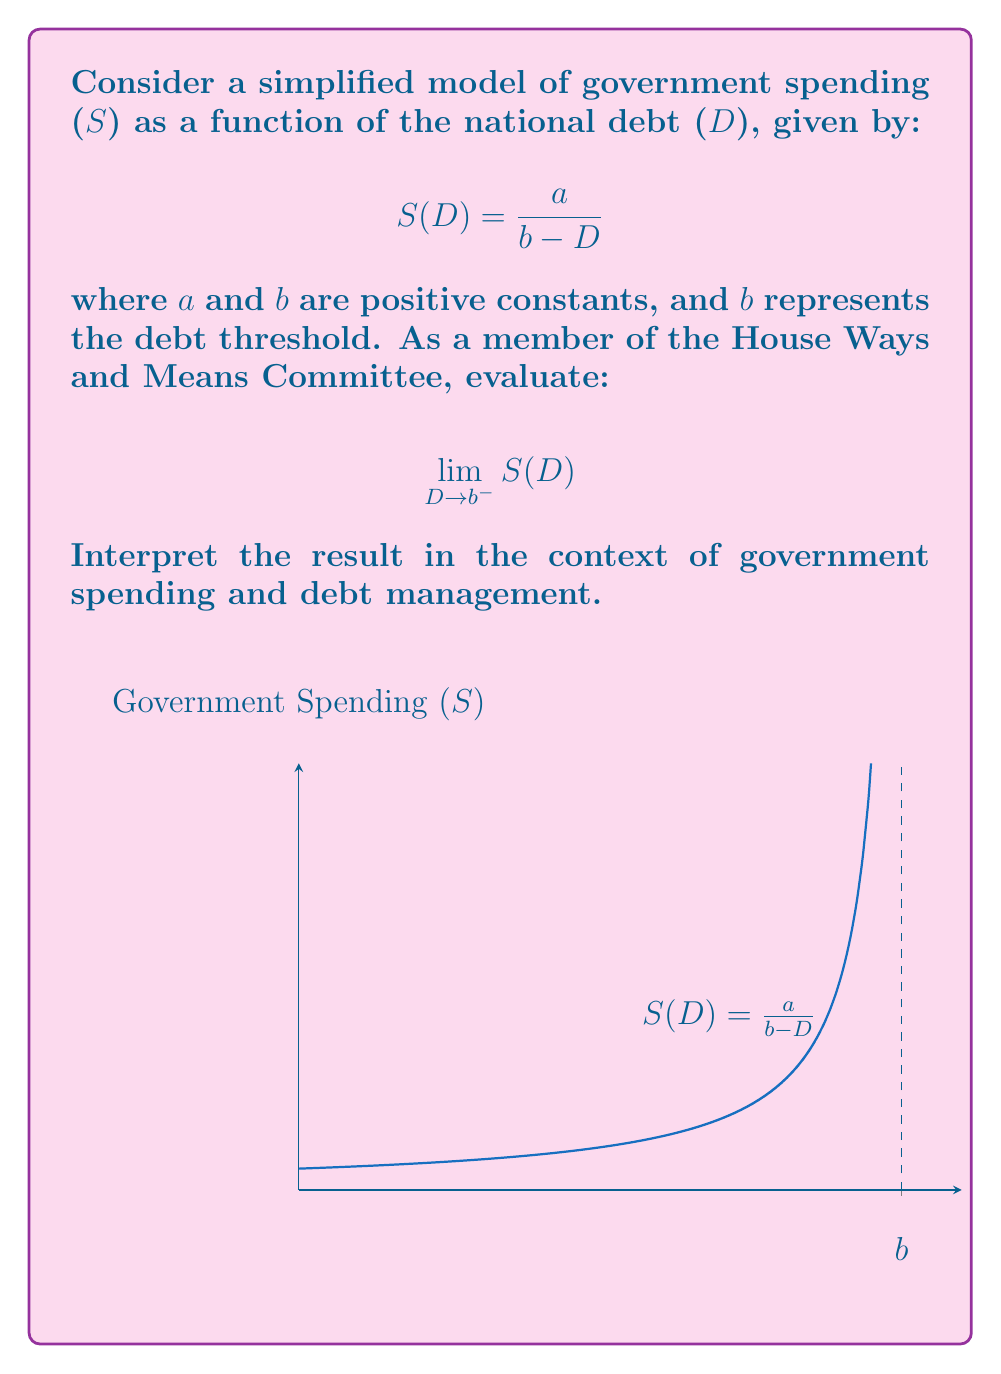Teach me how to tackle this problem. Let's approach this step-by-step:

1) The limit we're evaluating is:

   $$\lim_{D \to b^-} S(D) = \lim_{D \to b^-} \frac{a}{b - D}$$

2) As $D$ approaches $b$ from the left (indicated by $b^-$), the denominator $(b - D)$ approaches zero.

3) When a constant is divided by a value approaching zero, the result tends to infinity. Mathematically:

   $$\lim_{x \to 0^+} \frac{k}{x} = +\infty$$

   where $k$ is a positive constant.

4) In our case, $a$ is positive and $(b - D)$ is approaching zero from the right as $D$ approaches $b$ from the left.

5) Therefore:

   $$\lim_{D \to b^-} \frac{a}{b - D} = +\infty$$

Interpretation: As the national debt approaches the threshold $b$, government spending theoretically approaches infinity. This suggests that as debt nears the threshold, spending could increase dramatically, potentially leading to unsustainable fiscal policy.
Answer: $+\infty$ 